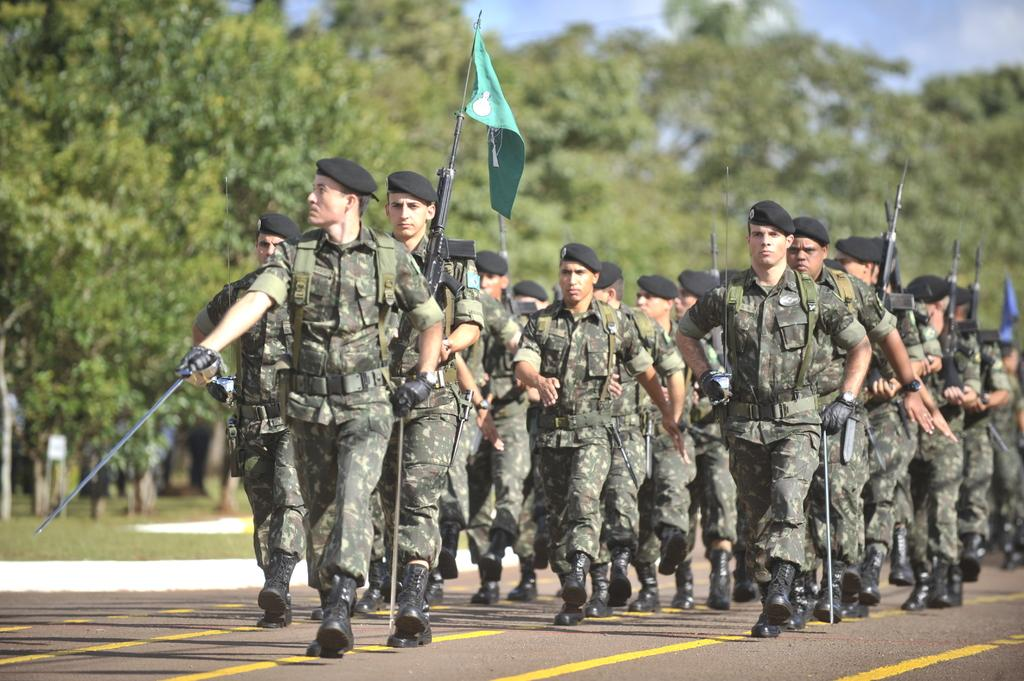What are the people in the image doing? The people in the image are walking in the center of the image. What are the people wearing? The people are wearing uniforms. What can be seen in the image besides the people walking? There are flags visible in the image, and there are trees and the sky in the background. What is at the bottom of the image? There is a road at the bottom of the image. What type of sea creature can be seen swimming in the image? There is no sea creature present in the image; it features people walking, flags, trees, and a road. What plant is being tasted by the people in the image? There is no plant being tasted in the image; the people are wearing uniforms and walking. 